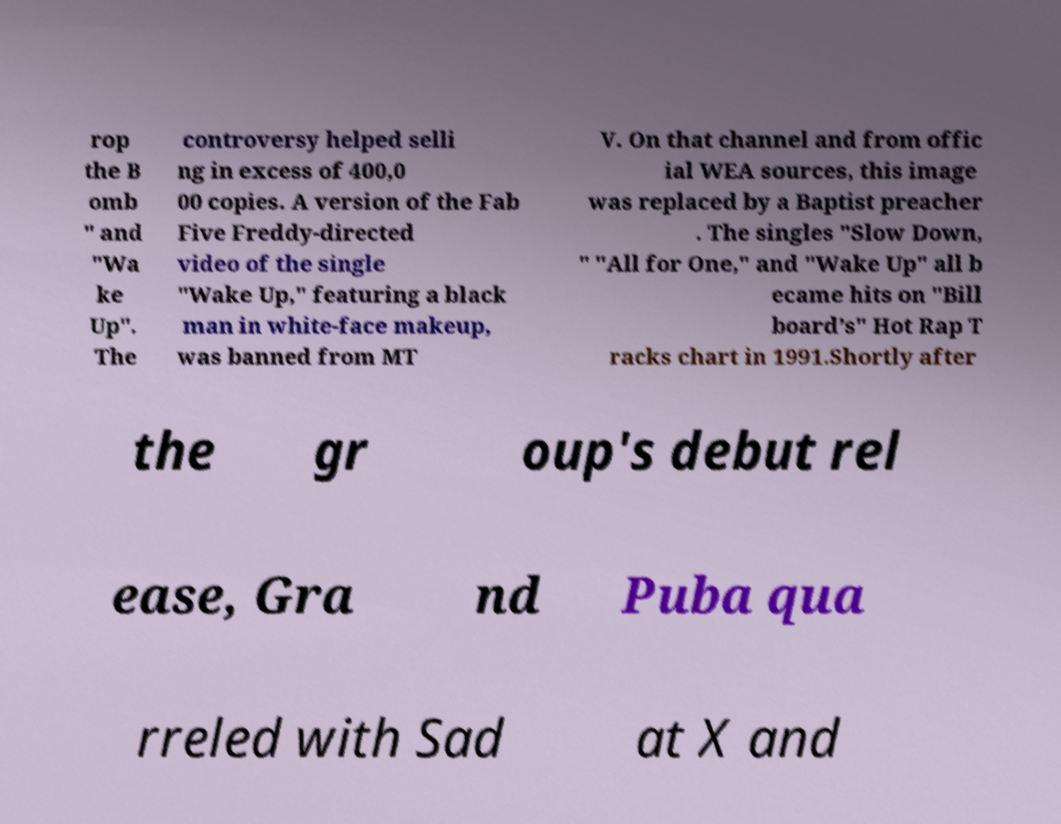I need the written content from this picture converted into text. Can you do that? rop the B omb " and "Wa ke Up". The controversy helped selli ng in excess of 400,0 00 copies. A version of the Fab Five Freddy-directed video of the single "Wake Up," featuring a black man in white-face makeup, was banned from MT V. On that channel and from offic ial WEA sources, this image was replaced by a Baptist preacher . The singles "Slow Down, " "All for One," and "Wake Up" all b ecame hits on "Bill board’s" Hot Rap T racks chart in 1991.Shortly after the gr oup's debut rel ease, Gra nd Puba qua rreled with Sad at X and 